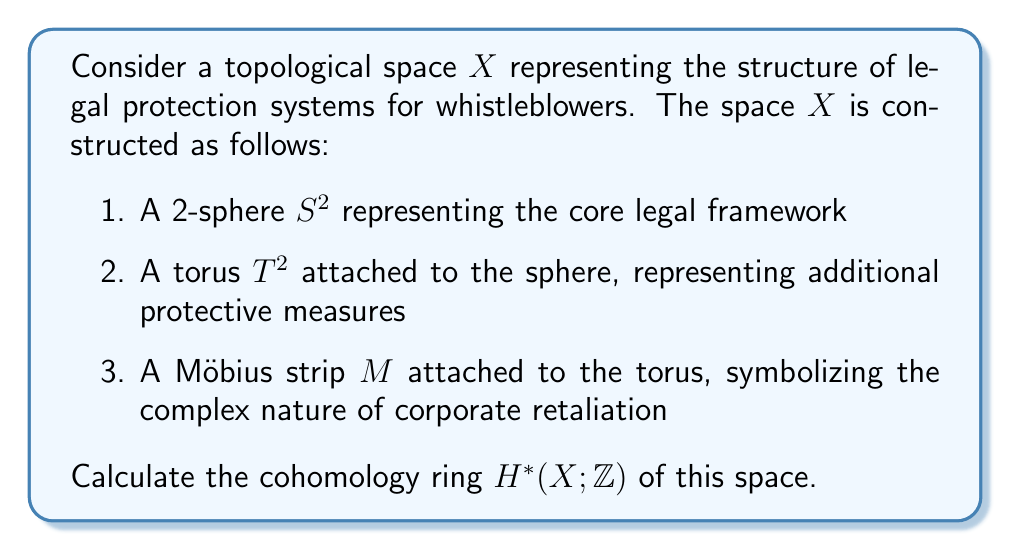Show me your answer to this math problem. To solve this problem, we'll use the following steps:

1. Identify the individual components and their cohomology groups
2. Analyze how these components are connected
3. Apply the Mayer-Vietoris sequence to compute the cohomology groups of $X$
4. Determine the ring structure

Step 1: Individual components

a) $S^2$: $H^0(S^2) \cong \mathbb{Z}$, $H^2(S^2) \cong \mathbb{Z}$, all others 0
b) $T^2$: $H^0(T^2) \cong \mathbb{Z}$, $H^1(T^2) \cong \mathbb{Z} \oplus \mathbb{Z}$, $H^2(T^2) \cong \mathbb{Z}$, all others 0
c) $M$: $H^0(M) \cong \mathbb{Z}$, $H^1(M) \cong \mathbb{Z}$, all others 0

Step 2: Connections

The torus is attached to the sphere along a circle, and the Möbius strip is attached to the torus along another circle. Let $A$ be the union of $S^2$ and $T^2$, and $B$ be the Möbius strip. Then $X = A \cup B$ and $A \cap B \simeq S^1$.

Step 3: Mayer-Vietoris sequence

We use the Mayer-Vietoris sequence for $A$ and $B$:

$$\cdots \to H^n(X) \to H^n(A) \oplus H^n(B) \to H^n(A \cap B) \to H^{n+1}(X) \to \cdots$$

First, we compute $H^*(A)$ using Mayer-Vietoris for $S^2$ and $T^2$:
$H^0(A) \cong \mathbb{Z}$
$H^1(A) \cong \mathbb{Z}$
$H^2(A) \cong \mathbb{Z} \oplus \mathbb{Z}$
$H^n(A) = 0$ for $n \geq 3$

Now we can compute $H^*(X)$:

$H^0(X) \cong \mathbb{Z}$
$H^1(X) \cong \mathbb{Z} \oplus \mathbb{Z}$
$H^2(X) \cong \mathbb{Z} \oplus \mathbb{Z}$
$H^n(X) = 0$ for $n \geq 3$

Step 4: Ring structure

The cup product structure is determined by:
- $H^1(X) \times H^1(X) \to H^2(X)$: One generator of $H^1(X)$ comes from $T^2$, and the other from $M$. Their cup product is zero.
- $H^2(X)$ is generated by the fundamental classes of $S^2$ and $T^2$.

Therefore, the cohomology ring $H^*(X; \mathbb{Z})$ is isomorphic to:

$$\mathbb{Z}[a,b,c,d] / (ab, ac, bc, a^2, b^2, c^2, d^2)$$

where $\deg(a) = \deg(b) = 1$, $\deg(c) = \deg(d) = 2$.
Answer: $H^*(X; \mathbb{Z}) \cong \mathbb{Z}[a,b,c,d] / (ab, ac, bc, a^2, b^2, c^2, d^2)$, where $\deg(a) = \deg(b) = 1$, $\deg(c) = \deg(d) = 2$ 